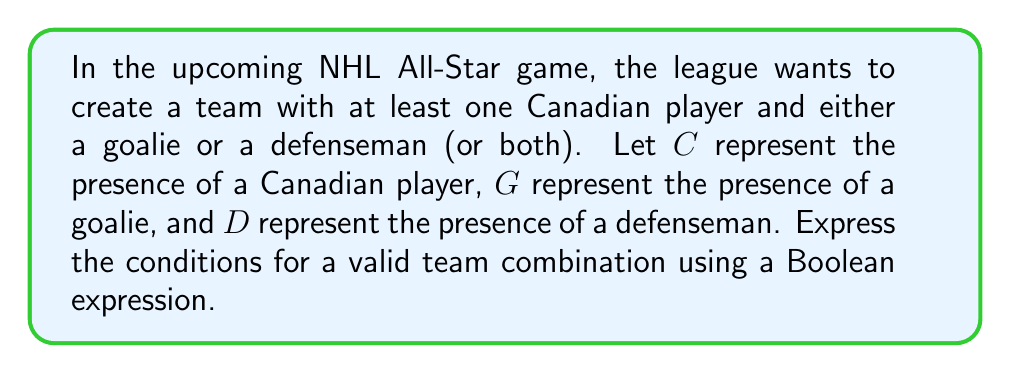Teach me how to tackle this problem. Let's break this down step-by-step:

1) We need at least one Canadian player, which is represented by C.

2) We also need either a goalie (G) or a defenseman (D) or both. This can be represented as (G OR D).

3) In Boolean algebra, OR is represented by the symbol $\lor$.

4) We need both conditions to be true, which is represented by AND in Boolean algebra. The AND operation is symbolized by $\land$.

5) Putting it all together, we get:

   $C \land (G \lor D)$

This expression reads as "C AND (G OR D)", which accurately represents the conditions given in the question.

To break it down further:
- C must be true (there must be a Canadian player)
- Either G or D (or both) must be true (there must be a goalie or a defenseman or both)

This Boolean expression will evaluate to true for any valid team combination that meets the specified criteria.
Answer: $C \land (G \lor D)$ 